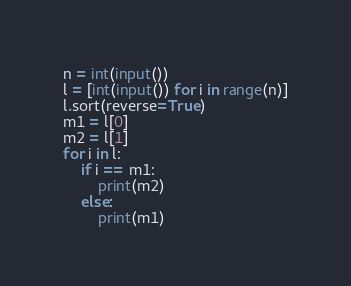<code> <loc_0><loc_0><loc_500><loc_500><_Python_>n = int(input())
l = [int(input()) for i in range(n)]
l.sort(reverse=True)
m1 = l[0]
m2 = l[1]
for i in l:
    if i == m1:
        print(m2)
    else:
        print(m1)</code> 